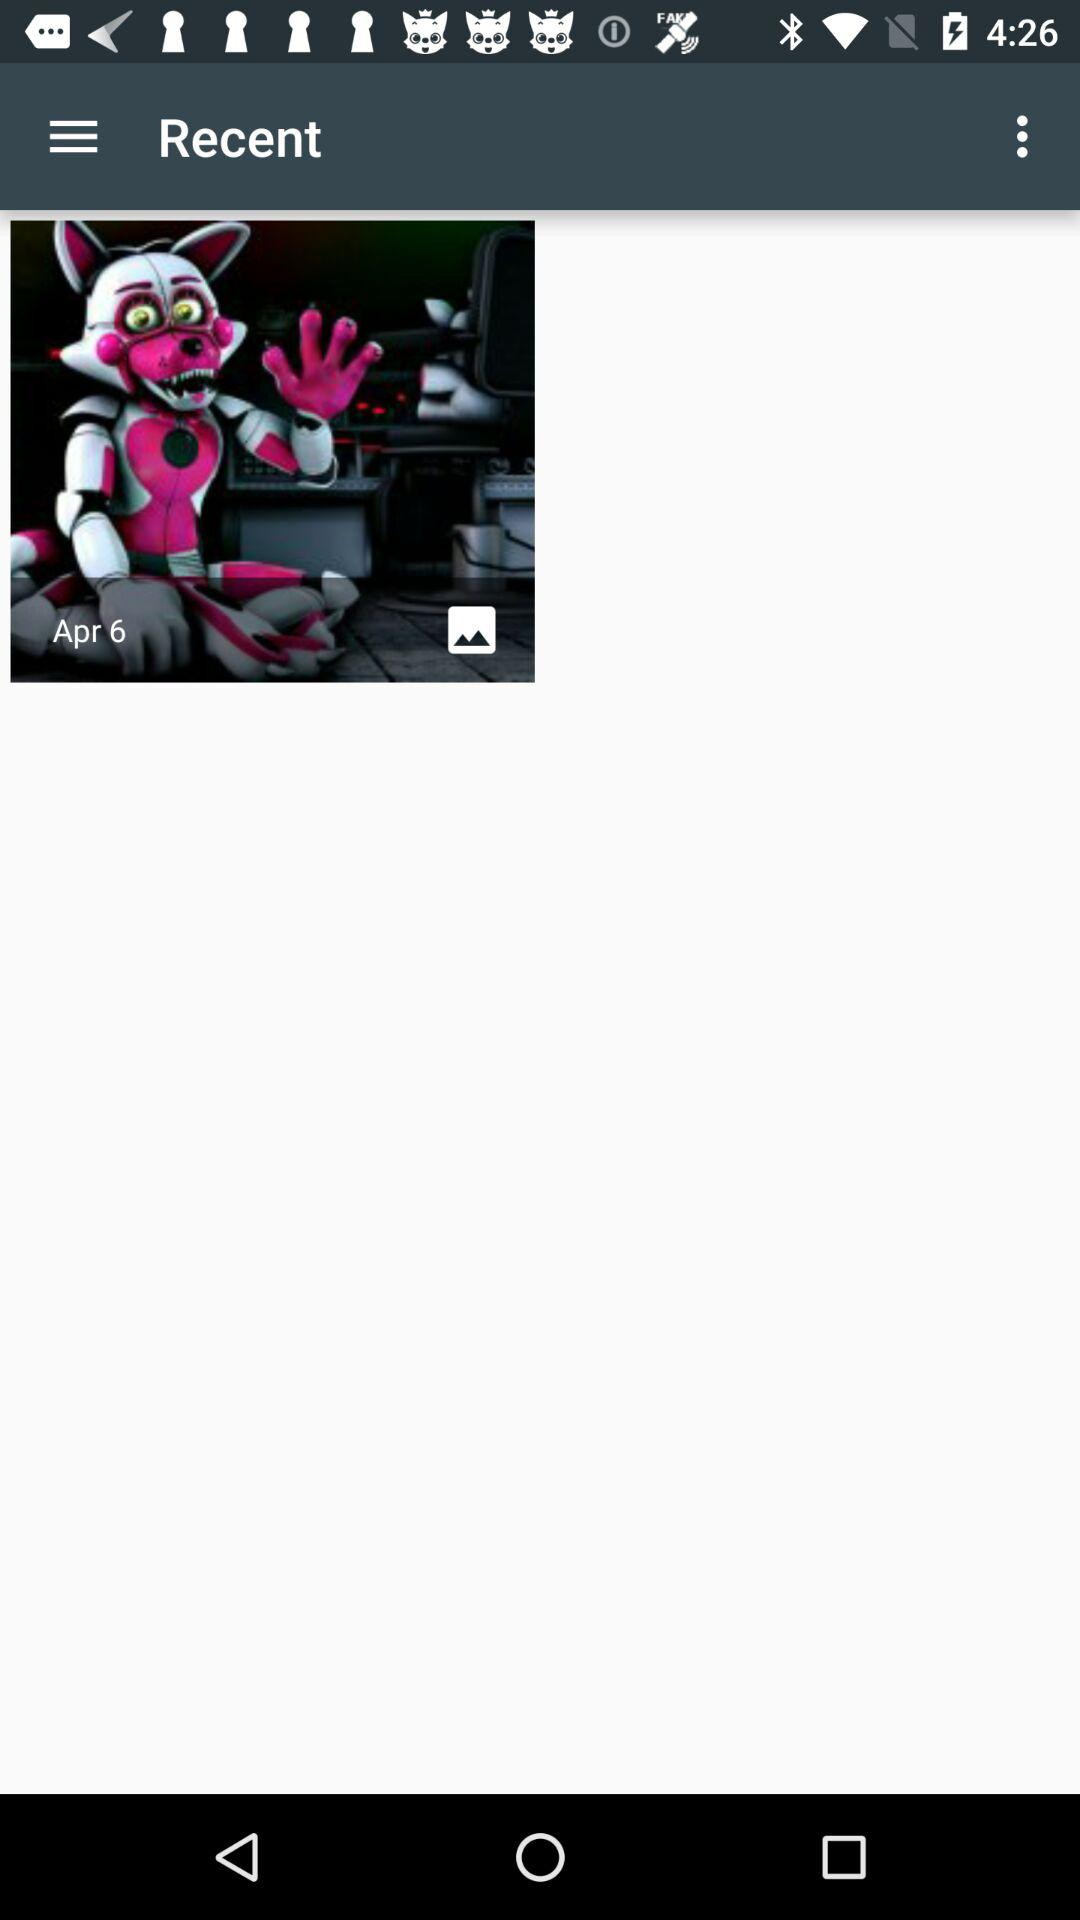On what date was the image saved? The image was saved on April 6. 